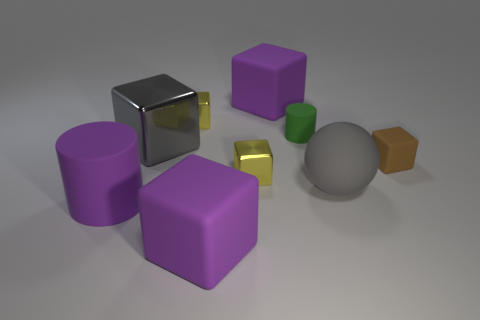Do the big shiny thing and the small rubber thing on the left side of the big matte sphere have the same shape?
Ensure brevity in your answer.  No. What is the color of the rubber cube that is both on the left side of the tiny brown rubber block and behind the purple cylinder?
Your answer should be very brief. Purple. Is there a big purple rubber thing that has the same shape as the brown thing?
Provide a succinct answer. Yes. Does the small matte block have the same color as the small matte cylinder?
Ensure brevity in your answer.  No. There is a tiny yellow shiny block behind the tiny brown thing; are there any purple matte cubes that are in front of it?
Your answer should be compact. Yes. How many things are either small yellow shiny blocks that are in front of the tiny green object or matte objects behind the large cylinder?
Offer a very short reply. 5. What number of objects are brown rubber objects or matte cubes that are to the right of the tiny green thing?
Provide a succinct answer. 1. How big is the purple thing behind the gray thing that is to the right of the purple matte thing in front of the large purple cylinder?
Provide a succinct answer. Large. What is the material of the cylinder that is the same size as the gray metallic thing?
Provide a short and direct response. Rubber. Is there another matte cylinder of the same size as the green cylinder?
Give a very brief answer. No. 